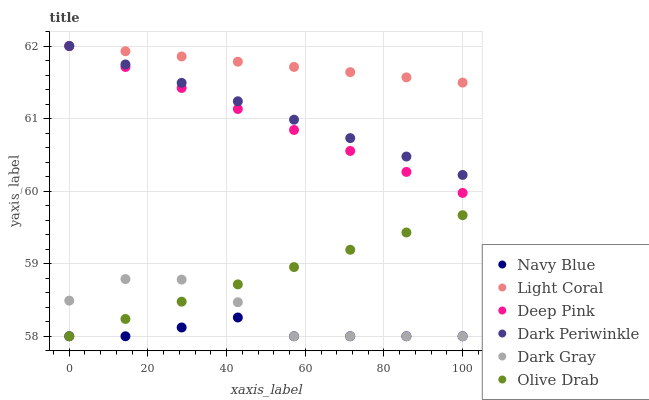Does Navy Blue have the minimum area under the curve?
Answer yes or no. Yes. Does Light Coral have the maximum area under the curve?
Answer yes or no. Yes. Does Deep Pink have the minimum area under the curve?
Answer yes or no. No. Does Deep Pink have the maximum area under the curve?
Answer yes or no. No. Is Dark Periwinkle the smoothest?
Answer yes or no. Yes. Is Dark Gray the roughest?
Answer yes or no. Yes. Is Deep Pink the smoothest?
Answer yes or no. No. Is Deep Pink the roughest?
Answer yes or no. No. Does Dark Gray have the lowest value?
Answer yes or no. Yes. Does Deep Pink have the lowest value?
Answer yes or no. No. Does Dark Periwinkle have the highest value?
Answer yes or no. Yes. Does Navy Blue have the highest value?
Answer yes or no. No. Is Dark Gray less than Dark Periwinkle?
Answer yes or no. Yes. Is Light Coral greater than Dark Gray?
Answer yes or no. Yes. Does Light Coral intersect Deep Pink?
Answer yes or no. Yes. Is Light Coral less than Deep Pink?
Answer yes or no. No. Is Light Coral greater than Deep Pink?
Answer yes or no. No. Does Dark Gray intersect Dark Periwinkle?
Answer yes or no. No. 